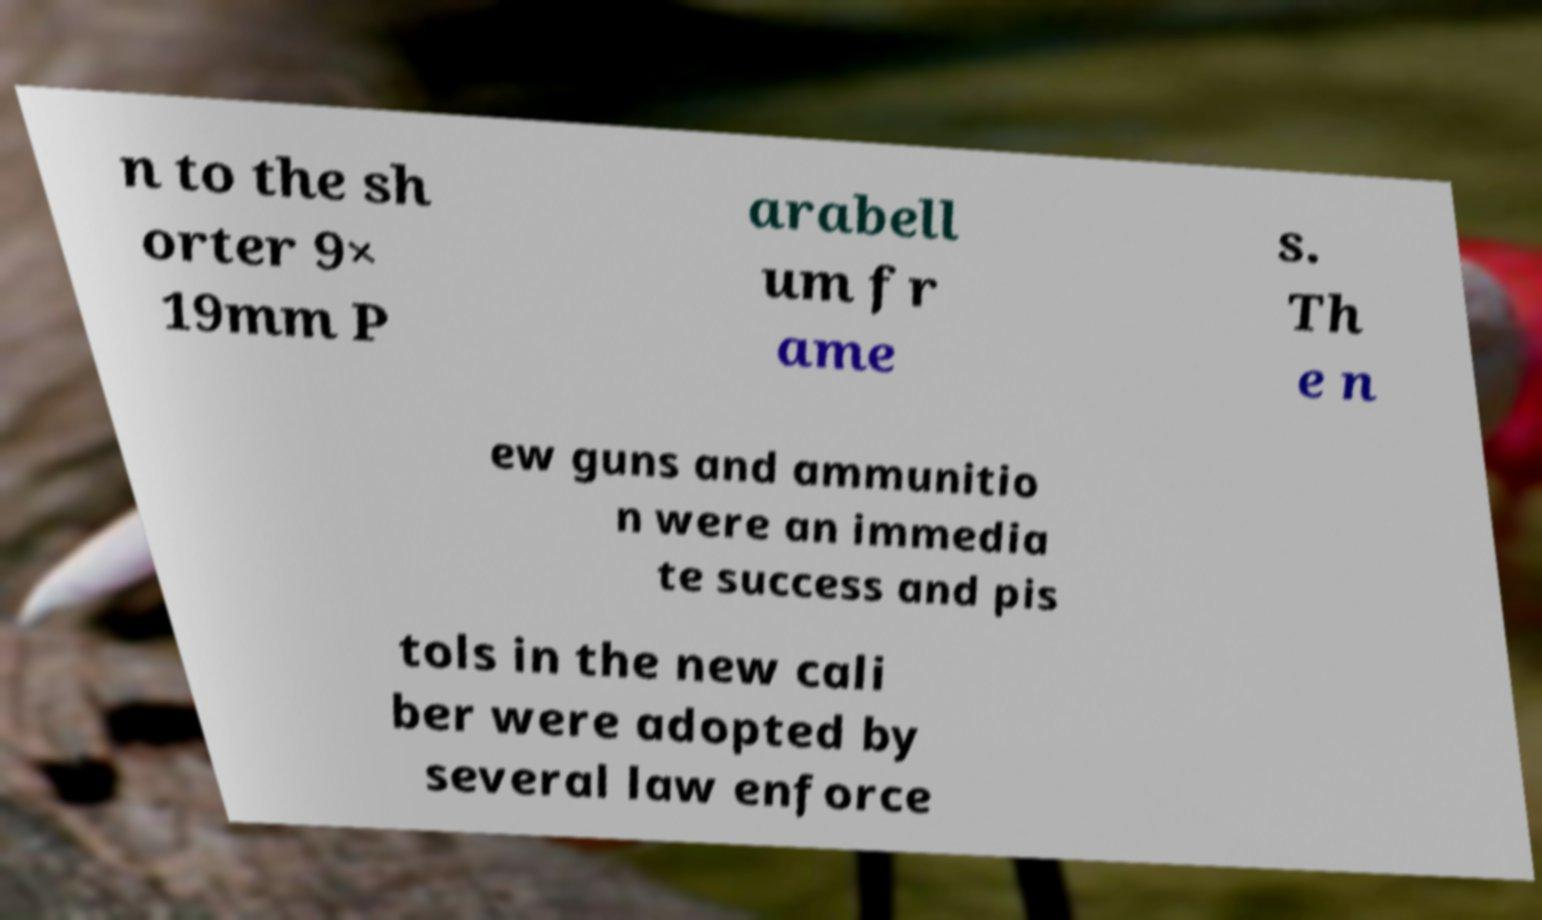Can you accurately transcribe the text from the provided image for me? n to the sh orter 9× 19mm P arabell um fr ame s. Th e n ew guns and ammunitio n were an immedia te success and pis tols in the new cali ber were adopted by several law enforce 